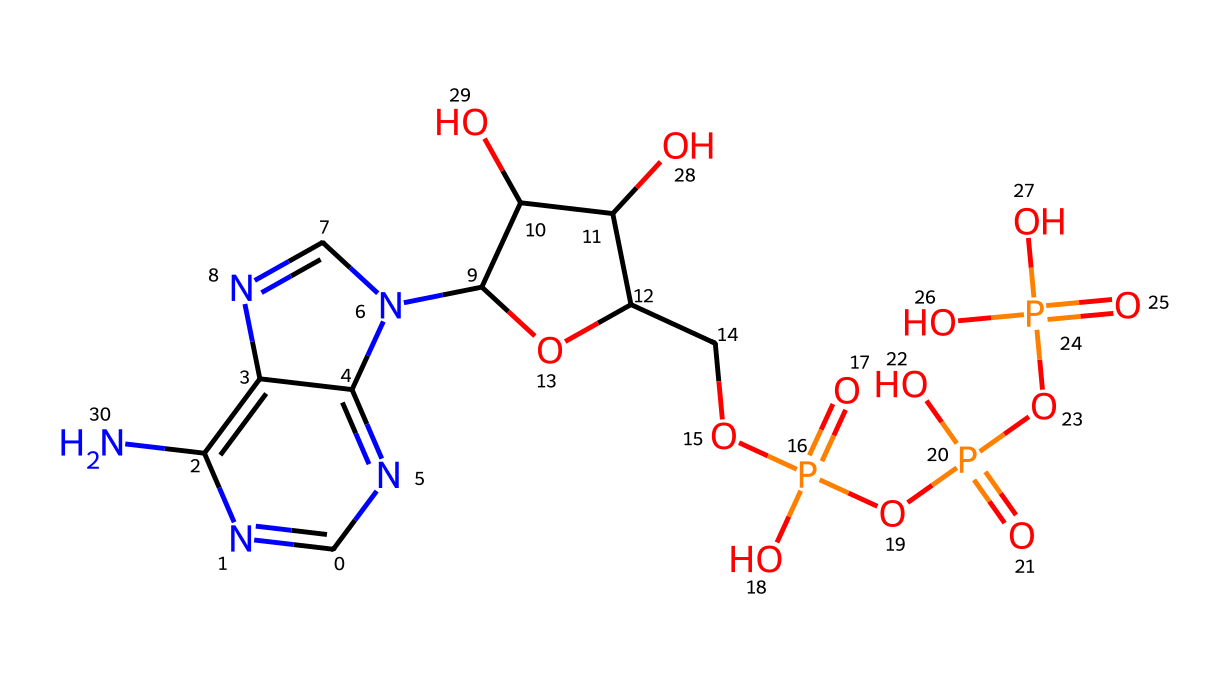What is the primary functional group in ATP? The primary functional group in ATP is the phosphate group, as indicated by the presence of multiple phosphorus atoms connected to oxygen atoms in the structure.
Answer: phosphate group How many oxygen atoms are present in ATP? By counting the oxygen atoms attached to phosphorus and within the molecule, there are a total of 8 oxygen atoms in the ATP structure.
Answer: 8 What is the total number of nitrogen atoms in ATP? The structure shows that there are 5 nitrogen atoms, which can be identified by examining the nitrogen-containing rings and other areas of the molecule.
Answer: 5 Which part of ATP is responsible for energy transfer? The phosphate bonds, specifically the high-energy bonds between the phosphate groups, are responsible for energy transfer during ATP hydrolysis.
Answer: phosphate bonds How many phosphate groups are present in ATP? The chemical structure includes three phosphate groups linked in a chain, recognizable by the 'P' atoms connected to 'O' atoms.
Answer: 3 What type of chemical is ATP categorized as? ATP is categorized as a nucleotide, which is confirmed by the presence of a ribose sugar, a nitrogenous base, and phosphate groups in its structure.
Answer: nucleotide 